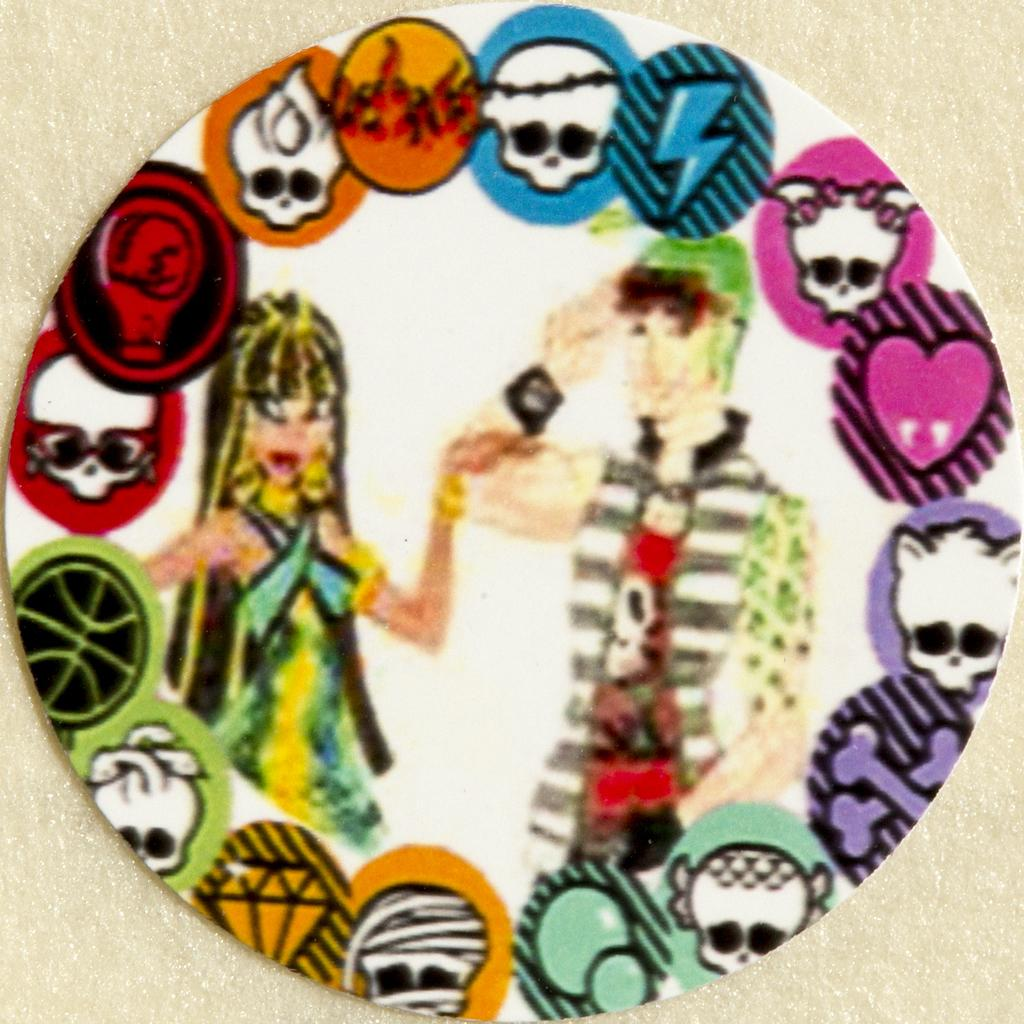What are the subjects depicted in the image? There is a depiction of a boy and a girl in the image. Can you describe the relationship between the two subjects? The provided facts do not give information about the relationship between the boy and the girl. Are there any other elements in the image besides the boy and the girl? The provided facts do not mention any other elements in the image. Where is the toothbrush located in the image? There is no toothbrush present in the image. What is the distance between the boy and the girl in the image? The provided facts do not give information about the distance between the boy and the girl. 